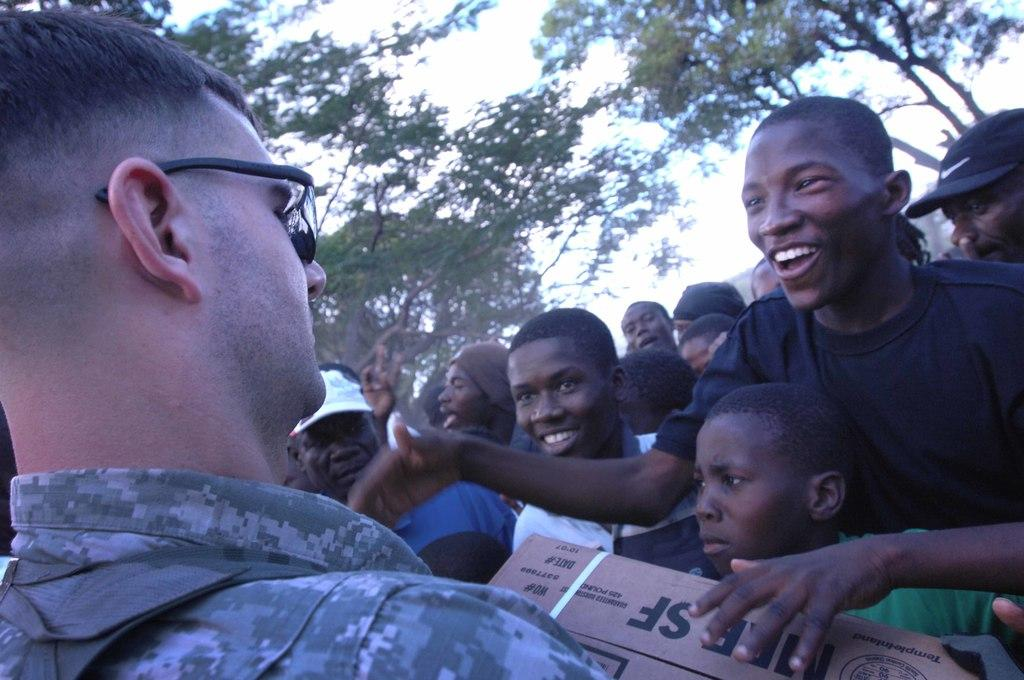What is the main subject in the foreground of the image? There is a man in the foreground of the image. What is the man holding in the image? The man is holding a cardboard box. What can be seen in the background of the image? There are persons and trees visible in the background of the image. What is visible at the top of the image? The sky is visible at the top of the image. What type of stick is the man using to activate the bomb in the image? There is no stick or bomb present in the image; the man is simply holding a cardboard box. 